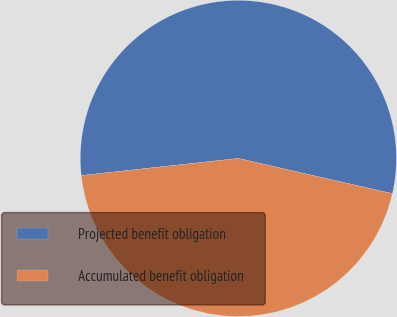Convert chart to OTSL. <chart><loc_0><loc_0><loc_500><loc_500><pie_chart><fcel>Projected benefit obligation<fcel>Accumulated benefit obligation<nl><fcel>55.3%<fcel>44.7%<nl></chart> 